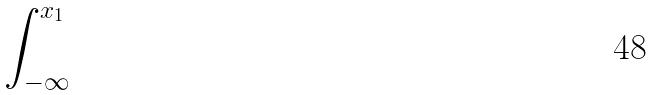<formula> <loc_0><loc_0><loc_500><loc_500>\int _ { - \infty } ^ { x _ { 1 } }</formula> 